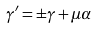Convert formula to latex. <formula><loc_0><loc_0><loc_500><loc_500>\gamma ^ { \prime } = \pm \gamma + \mu \alpha</formula> 